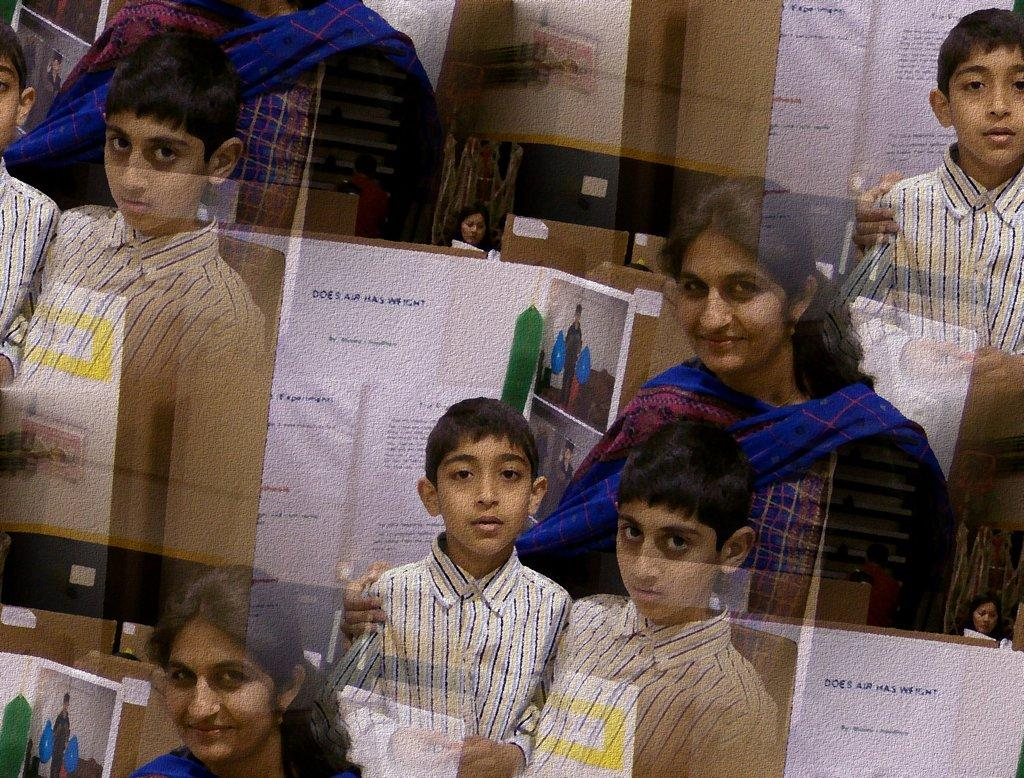How many kids are present in the image? There are two kids in the image. Who else is present in the image besides the kids? There is a woman in the image. What can be seen on the walls in the background of the image? There are posters with text and images on the walls in the background. What level of the building is the image taken from? The image does not provide any information about the level of the building, as it only shows the subjects and the background. 